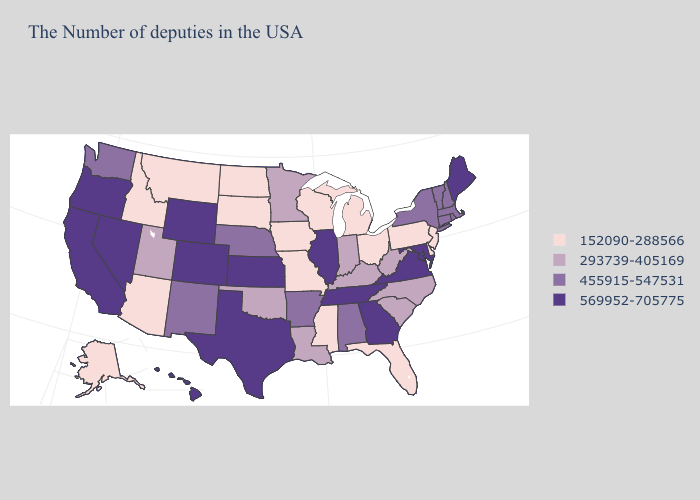Which states have the lowest value in the MidWest?
Keep it brief. Ohio, Michigan, Wisconsin, Missouri, Iowa, South Dakota, North Dakota. Name the states that have a value in the range 152090-288566?
Be succinct. New Jersey, Delaware, Pennsylvania, Ohio, Florida, Michigan, Wisconsin, Mississippi, Missouri, Iowa, South Dakota, North Dakota, Montana, Arizona, Idaho, Alaska. What is the lowest value in states that border Tennessee?
Give a very brief answer. 152090-288566. Does Montana have the lowest value in the West?
Concise answer only. Yes. What is the lowest value in states that border Indiana?
Be succinct. 152090-288566. What is the value of California?
Be succinct. 569952-705775. Name the states that have a value in the range 152090-288566?
Answer briefly. New Jersey, Delaware, Pennsylvania, Ohio, Florida, Michigan, Wisconsin, Mississippi, Missouri, Iowa, South Dakota, North Dakota, Montana, Arizona, Idaho, Alaska. What is the lowest value in the USA?
Concise answer only. 152090-288566. Does Minnesota have the same value as New York?
Quick response, please. No. Does Kansas have the lowest value in the MidWest?
Answer briefly. No. What is the highest value in the MidWest ?
Write a very short answer. 569952-705775. Does North Dakota have a lower value than Arizona?
Keep it brief. No. What is the value of Missouri?
Write a very short answer. 152090-288566. Does Hawaii have the same value as Nebraska?
Write a very short answer. No. Name the states that have a value in the range 152090-288566?
Write a very short answer. New Jersey, Delaware, Pennsylvania, Ohio, Florida, Michigan, Wisconsin, Mississippi, Missouri, Iowa, South Dakota, North Dakota, Montana, Arizona, Idaho, Alaska. 